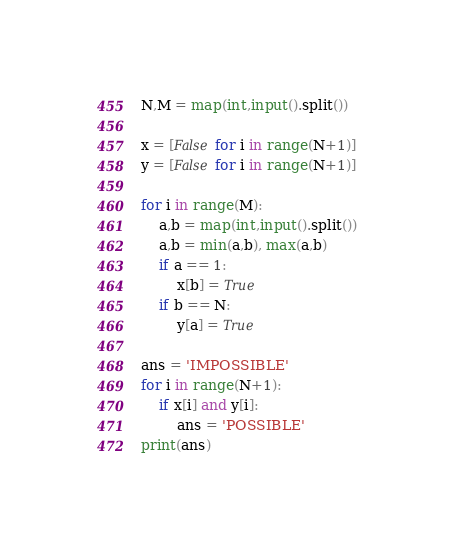Convert code to text. <code><loc_0><loc_0><loc_500><loc_500><_Python_>N,M = map(int,input().split())

x = [False for i in range(N+1)]
y = [False for i in range(N+1)]

for i in range(M):
    a,b = map(int,input().split())
    a,b = min(a,b), max(a,b)
    if a == 1:
        x[b] = True
    if b == N:
        y[a] = True

ans = 'IMPOSSIBLE'
for i in range(N+1):
    if x[i] and y[i]:
        ans = 'POSSIBLE'
print(ans)

</code> 